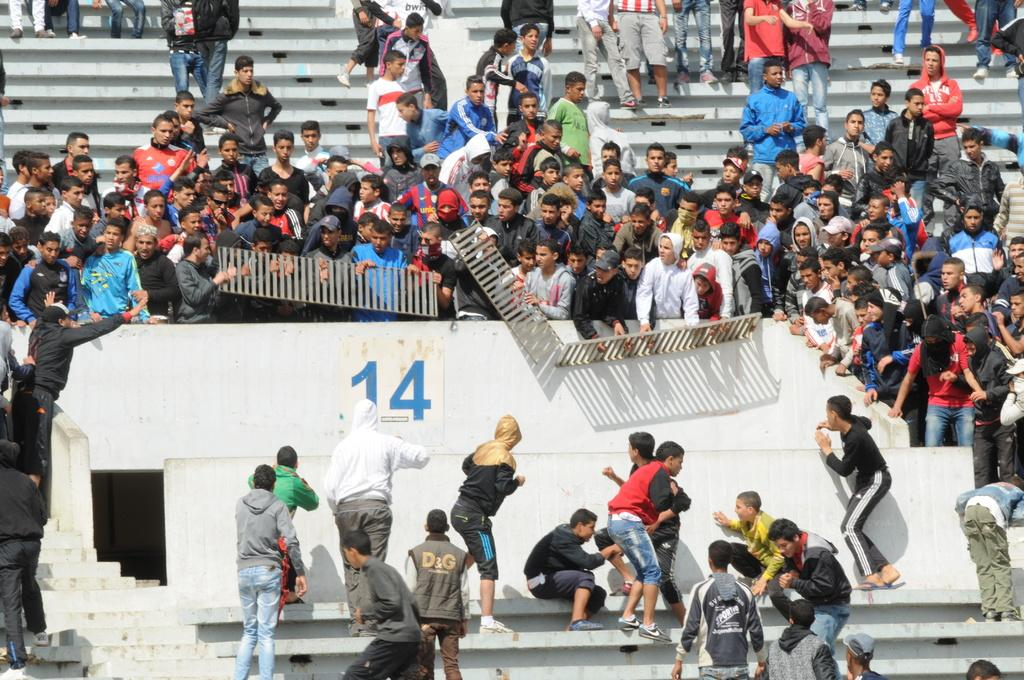How many people are in the image? There are many people in the image. What are the people in the image doing? The people appear to be fighting. What architectural feature can be seen at the bottom of the image? There are steps at the bottom of the image. What type of committee can be seen in the image? There is no committee present in the image; it features many people who appear to be fighting. Can you tell me how many robins are visible in the image? There are no robins present in the image. 